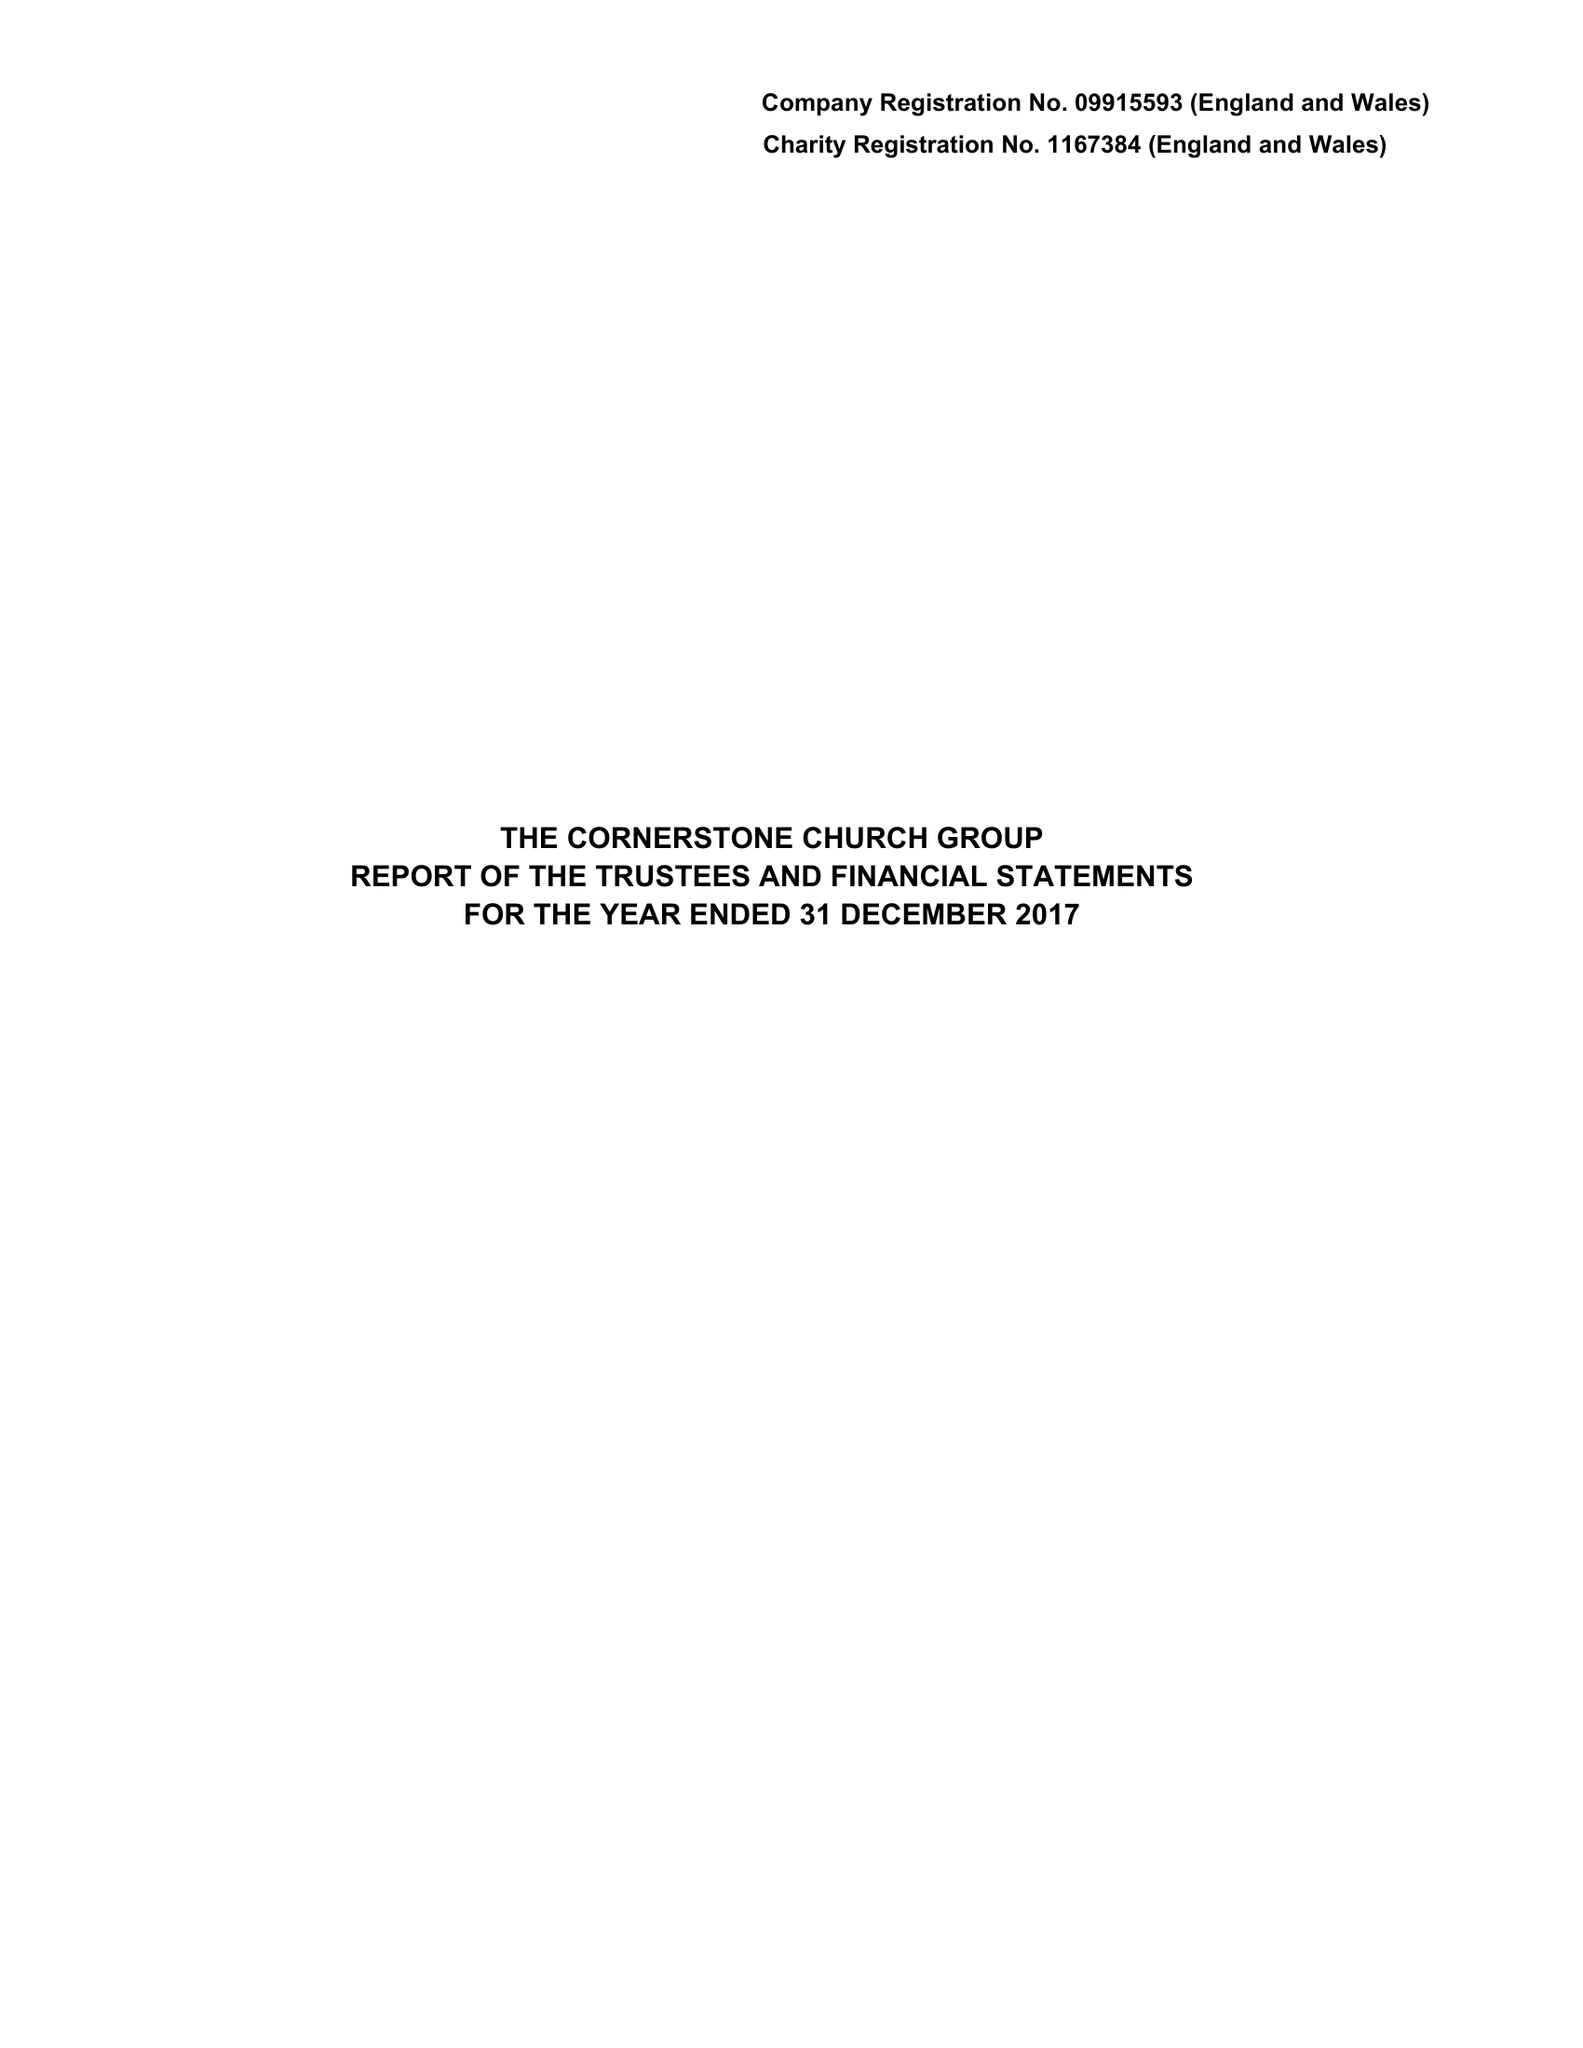What is the value for the charity_number?
Answer the question using a single word or phrase. 1167384 